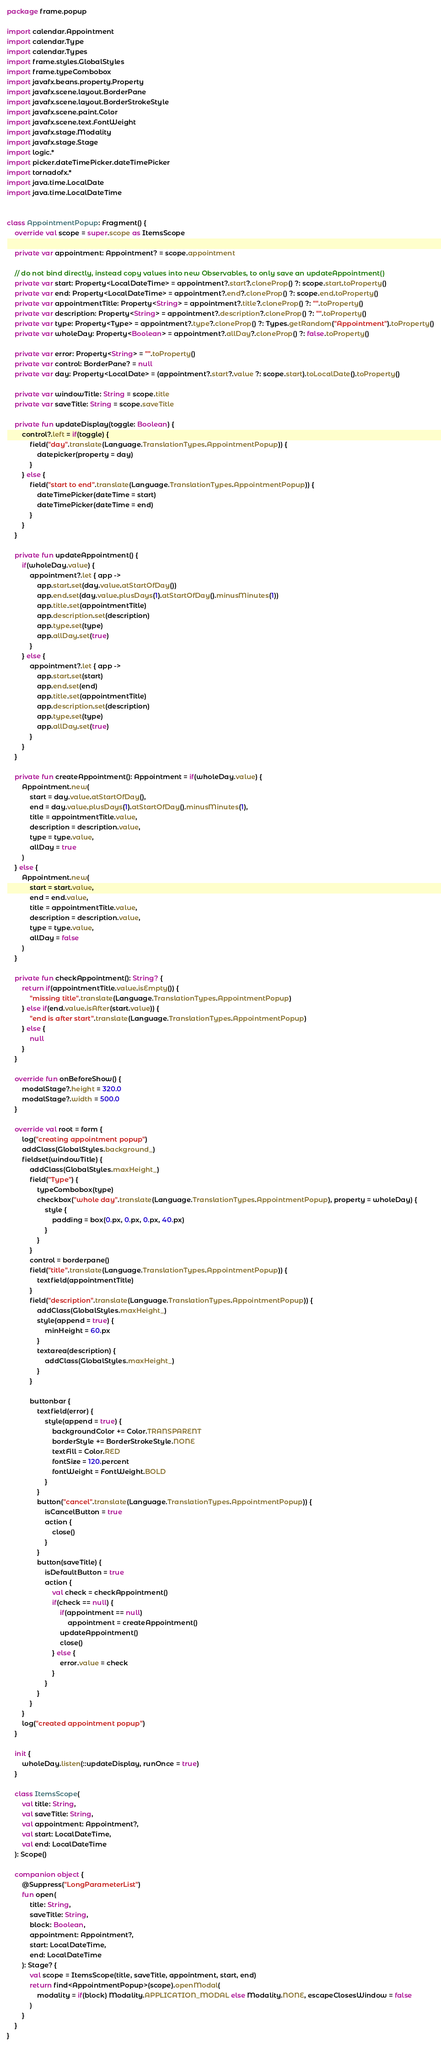<code> <loc_0><loc_0><loc_500><loc_500><_Kotlin_>package frame.popup

import calendar.Appointment
import calendar.Type
import calendar.Types
import frame.styles.GlobalStyles
import frame.typeCombobox
import javafx.beans.property.Property
import javafx.scene.layout.BorderPane
import javafx.scene.layout.BorderStrokeStyle
import javafx.scene.paint.Color
import javafx.scene.text.FontWeight
import javafx.stage.Modality
import javafx.stage.Stage
import logic.*
import picker.dateTimePicker.dateTimePicker
import tornadofx.*
import java.time.LocalDate
import java.time.LocalDateTime


class AppointmentPopup: Fragment() {
	override val scope = super.scope as ItemsScope

	private var appointment: Appointment? = scope.appointment

	// do not bind directly, instead copy values into new Observables, to only save an updateAppointment()
	private var start: Property<LocalDateTime> = appointment?.start?.cloneProp() ?: scope.start.toProperty()
	private var end: Property<LocalDateTime> = appointment?.end?.cloneProp() ?: scope.end.toProperty()
	private var appointmentTitle: Property<String> = appointment?.title?.cloneProp() ?: "".toProperty()
	private var description: Property<String> = appointment?.description?.cloneProp() ?: "".toProperty()
	private var type: Property<Type> = appointment?.type?.cloneProp() ?: Types.getRandom("Appointment").toProperty()
	private var wholeDay: Property<Boolean> = appointment?.allDay?.cloneProp() ?: false.toProperty()

	private var error: Property<String> = "".toProperty()
	private var control: BorderPane? = null
	private var day: Property<LocalDate> = (appointment?.start?.value ?: scope.start).toLocalDate().toProperty()

	private var windowTitle: String = scope.title
	private var saveTitle: String = scope.saveTitle

	private fun updateDisplay(toggle: Boolean) {
		control?.left = if(toggle) {
			field("day".translate(Language.TranslationTypes.AppointmentPopup)) {
				datepicker(property = day)
			}
		} else {
			field("start to end".translate(Language.TranslationTypes.AppointmentPopup)) {
				dateTimePicker(dateTime = start)
				dateTimePicker(dateTime = end)
			}
		}
	}

	private fun updateAppointment() {
		if(wholeDay.value) {
			appointment?.let { app ->
				app.start.set(day.value.atStartOfDay())
				app.end.set(day.value.plusDays(1).atStartOfDay().minusMinutes(1))
				app.title.set(appointmentTitle)
				app.description.set(description)
				app.type.set(type)
				app.allDay.set(true)
			}
		} else {
			appointment?.let { app ->
				app.start.set(start)
				app.end.set(end)
				app.title.set(appointmentTitle)
				app.description.set(description)
				app.type.set(type)
				app.allDay.set(true)
			}
		}
	}

	private fun createAppointment(): Appointment = if(wholeDay.value) {
		Appointment.new(
			start = day.value.atStartOfDay(),
			end = day.value.plusDays(1).atStartOfDay().minusMinutes(1),
			title = appointmentTitle.value,
			description = description.value,
			type = type.value,
			allDay = true
		)
	} else {
		Appointment.new(
			start = start.value,
			end = end.value,
			title = appointmentTitle.value,
			description = description.value,
			type = type.value,
			allDay = false
		)
	}

	private fun checkAppointment(): String? {
		return if(appointmentTitle.value.isEmpty()) {
			"missing title".translate(Language.TranslationTypes.AppointmentPopup)
		} else if(end.value.isAfter(start.value)) {
			"end is after start".translate(Language.TranslationTypes.AppointmentPopup)
		} else {
			null
		}
	}

	override fun onBeforeShow() {
		modalStage?.height = 320.0
		modalStage?.width = 500.0
	}

	override val root = form {
		log("creating appointment popup")
		addClass(GlobalStyles.background_)
		fieldset(windowTitle) {
			addClass(GlobalStyles.maxHeight_)
			field("Type") {
				typeCombobox(type)
				checkbox("whole day".translate(Language.TranslationTypes.AppointmentPopup), property = wholeDay) {
					style {
						padding = box(0.px, 0.px, 0.px, 40.px)
					}
				}
			}
			control = borderpane()
			field("title".translate(Language.TranslationTypes.AppointmentPopup)) {
				textfield(appointmentTitle)
			}
			field("description".translate(Language.TranslationTypes.AppointmentPopup)) {
				addClass(GlobalStyles.maxHeight_)
				style(append = true) {
					minHeight = 60.px
				}
				textarea(description) {
					addClass(GlobalStyles.maxHeight_)
				}
			}

			buttonbar {
				textfield(error) {
					style(append = true) {
						backgroundColor += Color.TRANSPARENT
						borderStyle += BorderStrokeStyle.NONE
						textFill = Color.RED
						fontSize = 120.percent
						fontWeight = FontWeight.BOLD
					}
				}
				button("cancel".translate(Language.TranslationTypes.AppointmentPopup)) {
					isCancelButton = true
					action {
						close()
					}
				}
				button(saveTitle) {
					isDefaultButton = true
					action {
						val check = checkAppointment()
						if(check == null) {
							if(appointment == null)
								appointment = createAppointment()
							updateAppointment()
							close()
						} else {
							error.value = check
						}
					}
				}
			}
		}
		log("created appointment popup")
	}

	init {
		wholeDay.listen(::updateDisplay, runOnce = true)
	}

	class ItemsScope(
		val title: String,
		val saveTitle: String,
		val appointment: Appointment?,
		val start: LocalDateTime,
		val end: LocalDateTime
	): Scope()

	companion object {
		@Suppress("LongParameterList")
		fun open(
			title: String,
			saveTitle: String,
			block: Boolean,
			appointment: Appointment?,
			start: LocalDateTime,
			end: LocalDateTime
		): Stage? {
			val scope = ItemsScope(title, saveTitle, appointment, start, end)
			return find<AppointmentPopup>(scope).openModal(
				modality = if(block) Modality.APPLICATION_MODAL else Modality.NONE, escapeClosesWindow = false
			)
		}
	}
}
</code> 